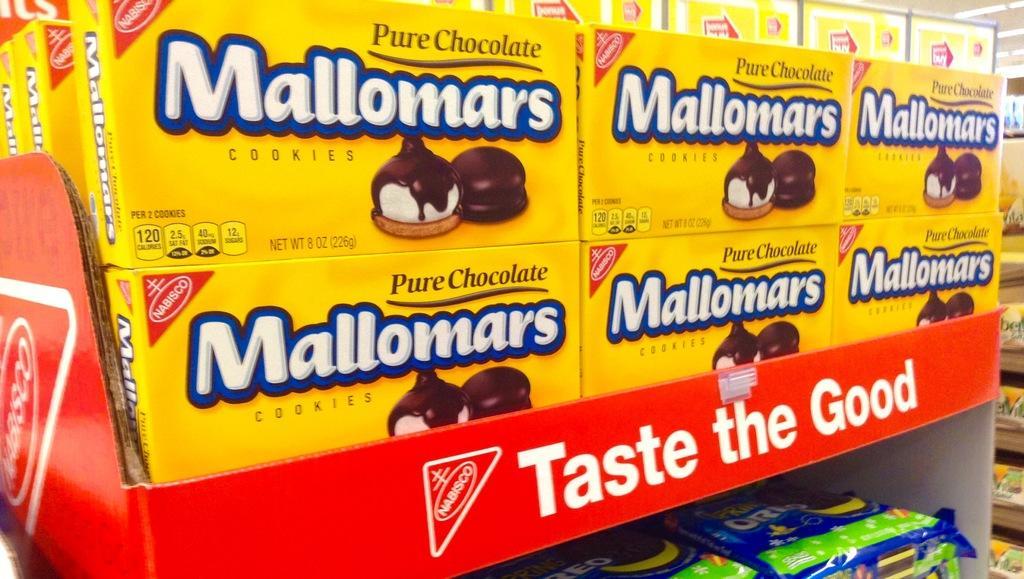Please provide a concise description of this image. This picture shows chocolate cookies boxes in a store. 